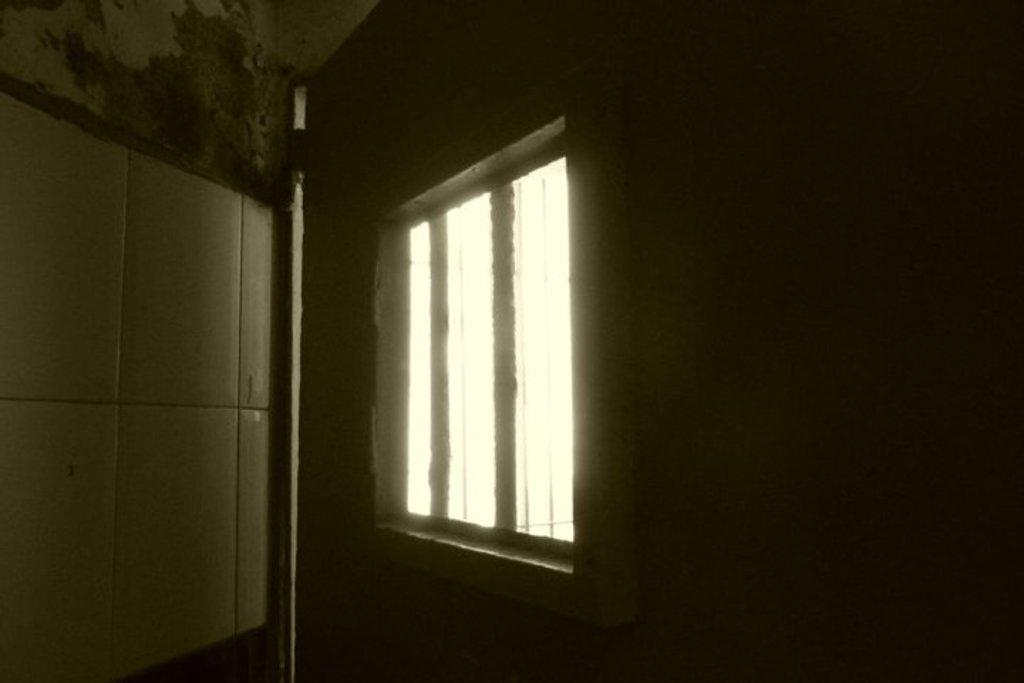What is the main subject in the center of the image? There is a window in the center of the image. What type of fowl can be seen comfortably sitting on the window sill in the image? There is no fowl present in the image, and the window sill is not visible. 